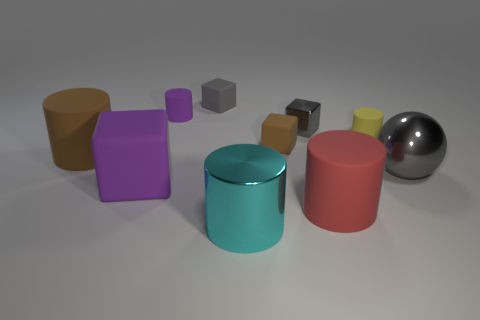How many objects are either gray objects that are behind the brown cylinder or large matte blocks?
Ensure brevity in your answer.  3. What number of other objects are there of the same color as the small metal cube?
Provide a succinct answer. 2. Do the tiny shiny thing and the big metal sphere on the right side of the large red object have the same color?
Your response must be concise. Yes. The other large matte thing that is the same shape as the big red thing is what color?
Your response must be concise. Brown. Is the material of the cyan object the same as the large cylinder that is behind the red thing?
Offer a very short reply. No. The small shiny block is what color?
Offer a terse response. Gray. What is the color of the big metallic thing that is right of the large metallic thing that is in front of the gray metal thing in front of the brown matte block?
Offer a very short reply. Gray. There is a large gray shiny thing; does it have the same shape as the small rubber thing that is in front of the tiny yellow matte cylinder?
Provide a succinct answer. No. The large matte thing that is to the left of the small brown rubber block and in front of the big sphere is what color?
Make the answer very short. Purple. Are there any brown things of the same shape as the tiny purple rubber thing?
Give a very brief answer. Yes. 